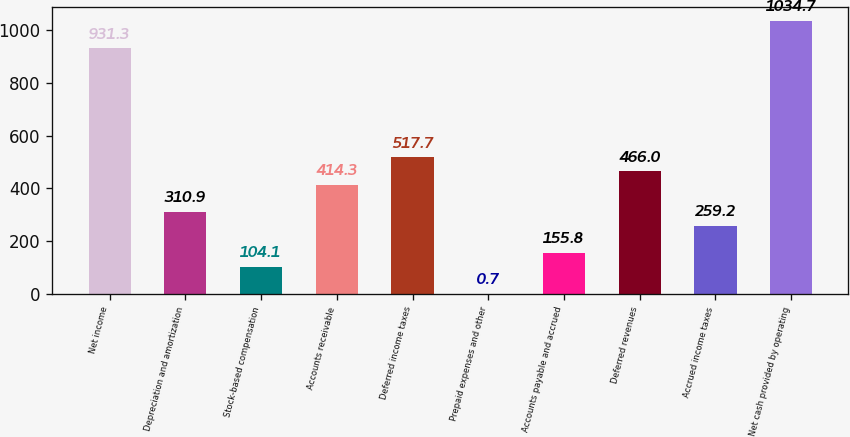<chart> <loc_0><loc_0><loc_500><loc_500><bar_chart><fcel>Net income<fcel>Depreciation and amortization<fcel>Stock-based compensation<fcel>Accounts receivable<fcel>Deferred income taxes<fcel>Prepaid expenses and other<fcel>Accounts payable and accrued<fcel>Deferred revenues<fcel>Accrued income taxes<fcel>Net cash provided by operating<nl><fcel>931.3<fcel>310.9<fcel>104.1<fcel>414.3<fcel>517.7<fcel>0.7<fcel>155.8<fcel>466<fcel>259.2<fcel>1034.7<nl></chart> 